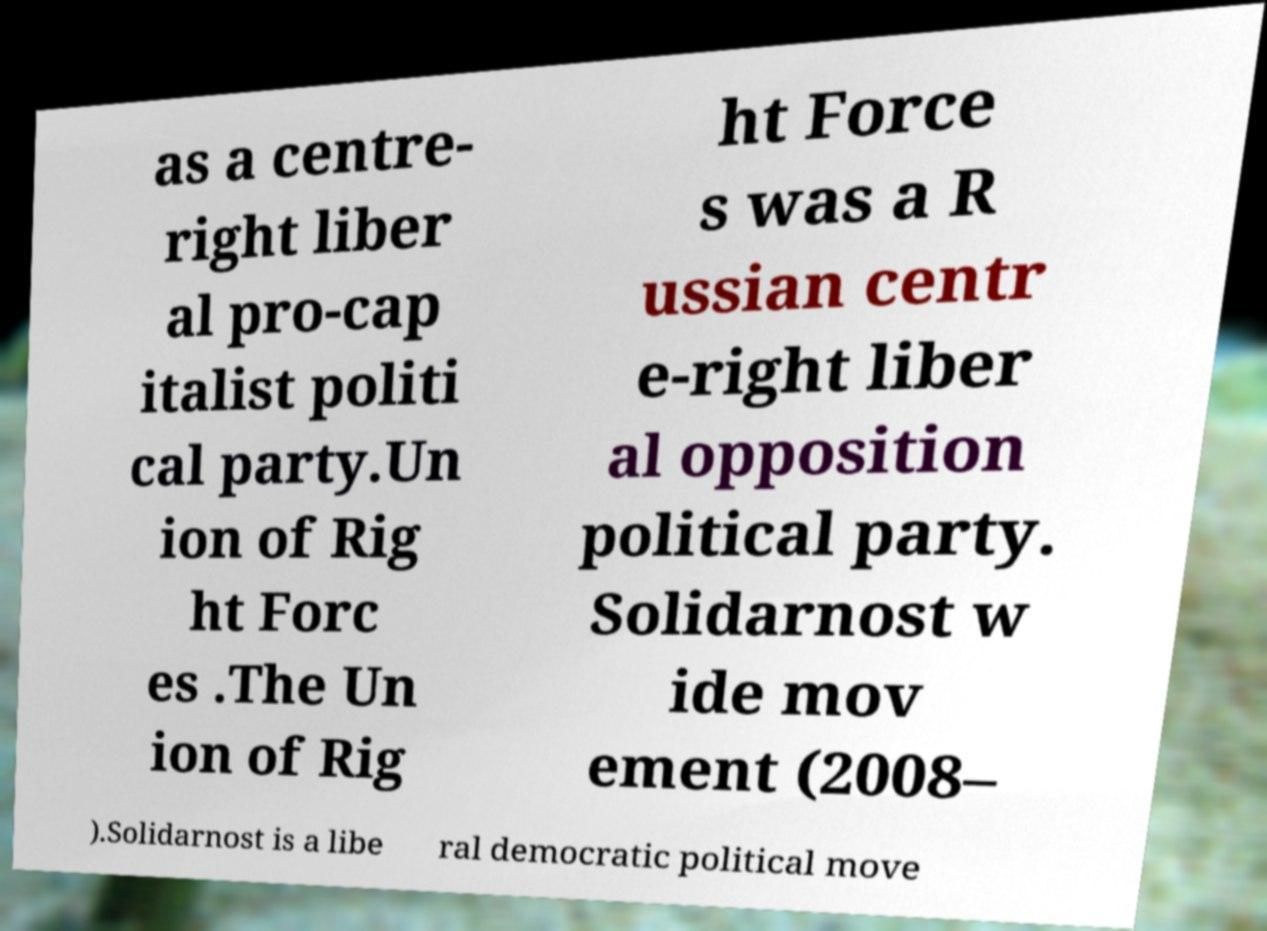Please identify and transcribe the text found in this image. as a centre- right liber al pro-cap italist politi cal party.Un ion of Rig ht Forc es .The Un ion of Rig ht Force s was a R ussian centr e-right liber al opposition political party. Solidarnost w ide mov ement (2008– ).Solidarnost is a libe ral democratic political move 